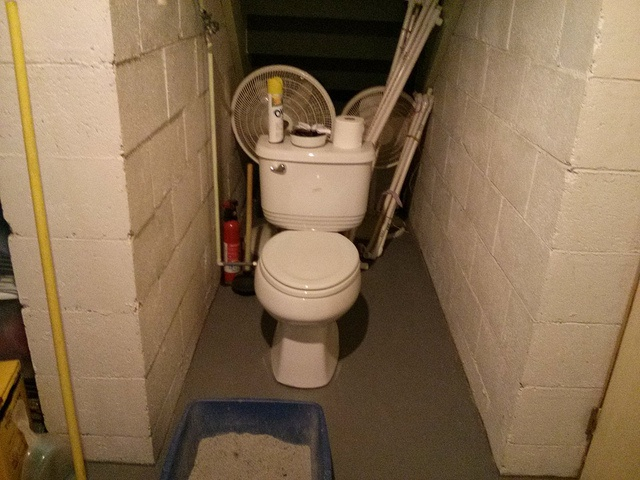Describe the objects in this image and their specific colors. I can see a toilet in tan, maroon, and gray tones in this image. 